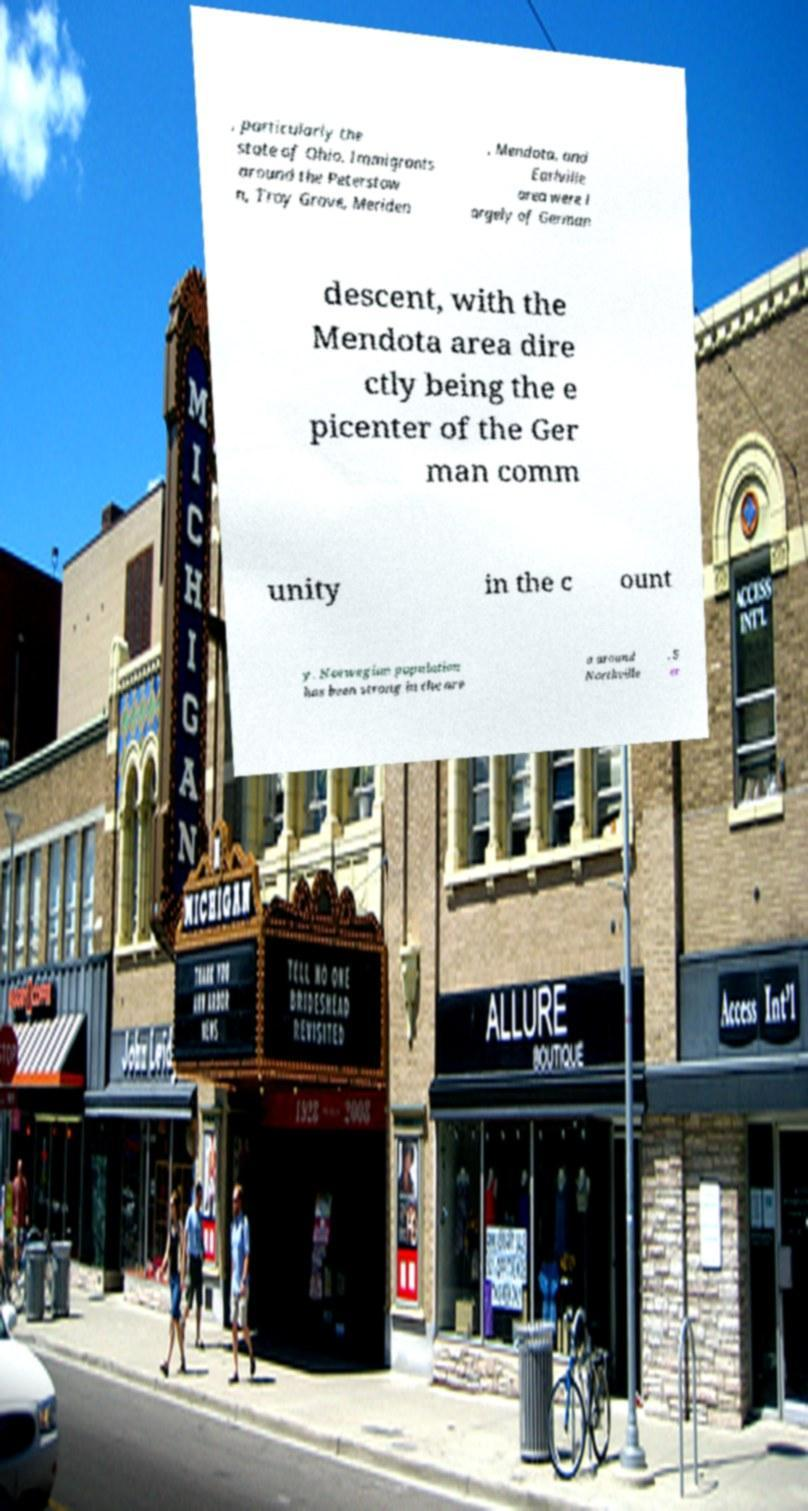I need the written content from this picture converted into text. Can you do that? , particularly the state of Ohio. Immigrants around the Peterstow n, Troy Grove, Meriden , Mendota, and Earlville area were l argely of German descent, with the Mendota area dire ctly being the e picenter of the Ger man comm unity in the c ount y. Norwegian population has been strong in the are a around Northville , S er 